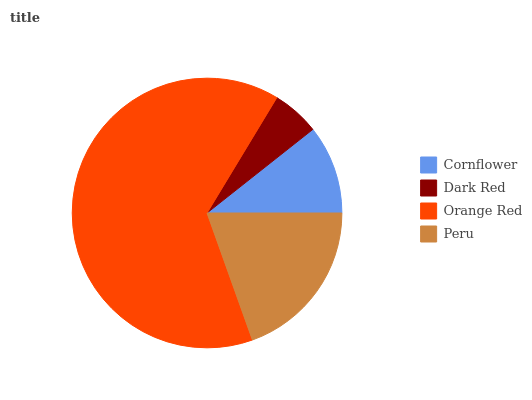Is Dark Red the minimum?
Answer yes or no. Yes. Is Orange Red the maximum?
Answer yes or no. Yes. Is Orange Red the minimum?
Answer yes or no. No. Is Dark Red the maximum?
Answer yes or no. No. Is Orange Red greater than Dark Red?
Answer yes or no. Yes. Is Dark Red less than Orange Red?
Answer yes or no. Yes. Is Dark Red greater than Orange Red?
Answer yes or no. No. Is Orange Red less than Dark Red?
Answer yes or no. No. Is Peru the high median?
Answer yes or no. Yes. Is Cornflower the low median?
Answer yes or no. Yes. Is Dark Red the high median?
Answer yes or no. No. Is Orange Red the low median?
Answer yes or no. No. 